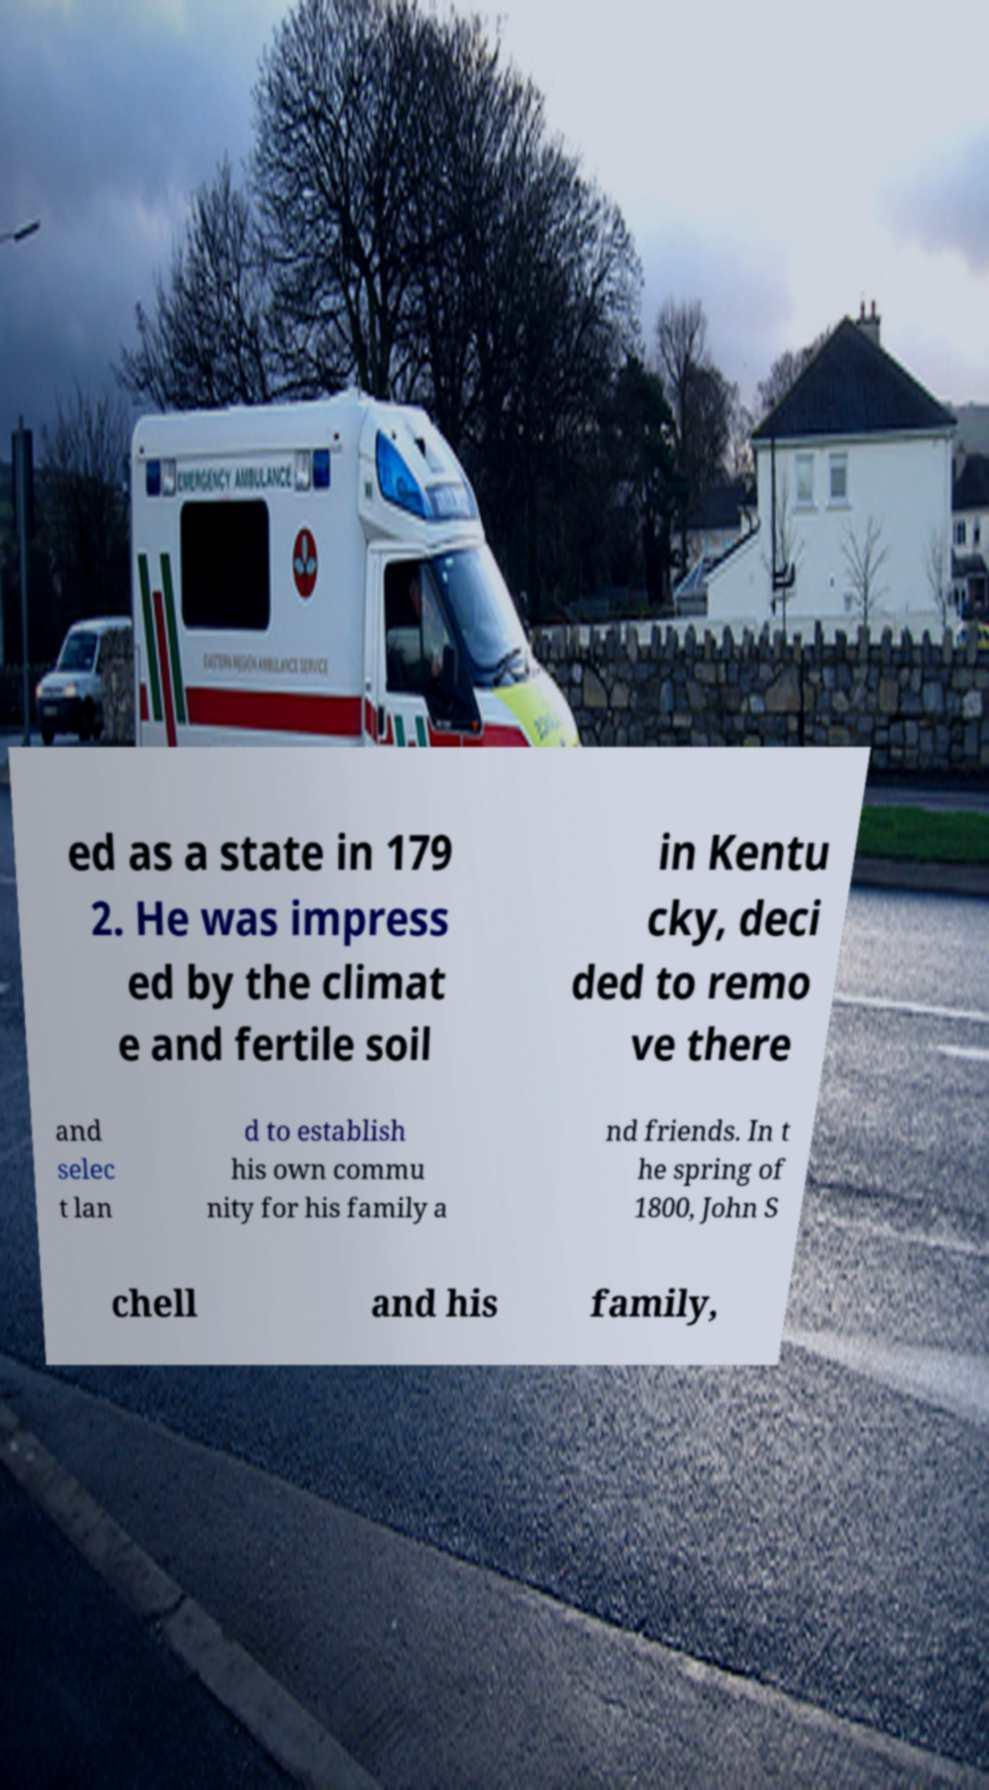There's text embedded in this image that I need extracted. Can you transcribe it verbatim? ed as a state in 179 2. He was impress ed by the climat e and fertile soil in Kentu cky, deci ded to remo ve there and selec t lan d to establish his own commu nity for his family a nd friends. In t he spring of 1800, John S chell and his family, 